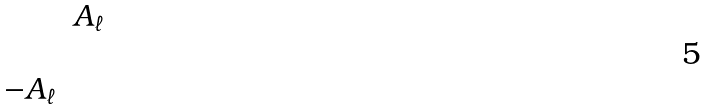Convert formula to latex. <formula><loc_0><loc_0><loc_500><loc_500>\begin{matrix} & A _ { \ell } \\ & \\ - A _ { \ell } & \end{matrix}</formula> 